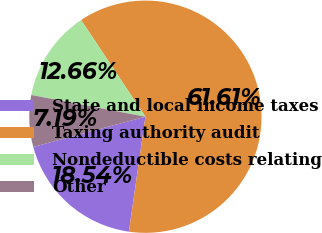Convert chart to OTSL. <chart><loc_0><loc_0><loc_500><loc_500><pie_chart><fcel>State and local income taxes<fcel>Taxing authority audit<fcel>Nondeductible costs relating<fcel>Other<nl><fcel>18.54%<fcel>61.61%<fcel>12.66%<fcel>7.19%<nl></chart> 